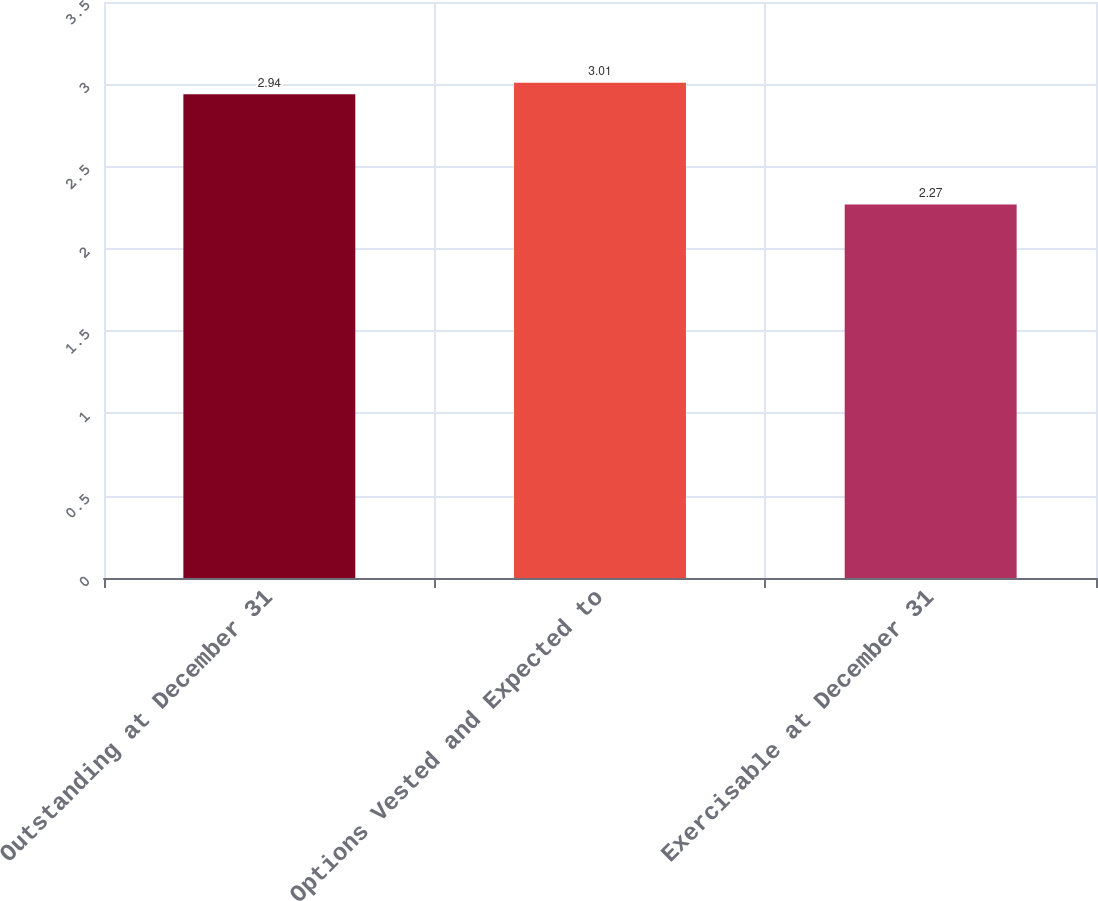Convert chart. <chart><loc_0><loc_0><loc_500><loc_500><bar_chart><fcel>Outstanding at December 31<fcel>Options Vested and Expected to<fcel>Exercisable at December 31<nl><fcel>2.94<fcel>3.01<fcel>2.27<nl></chart> 